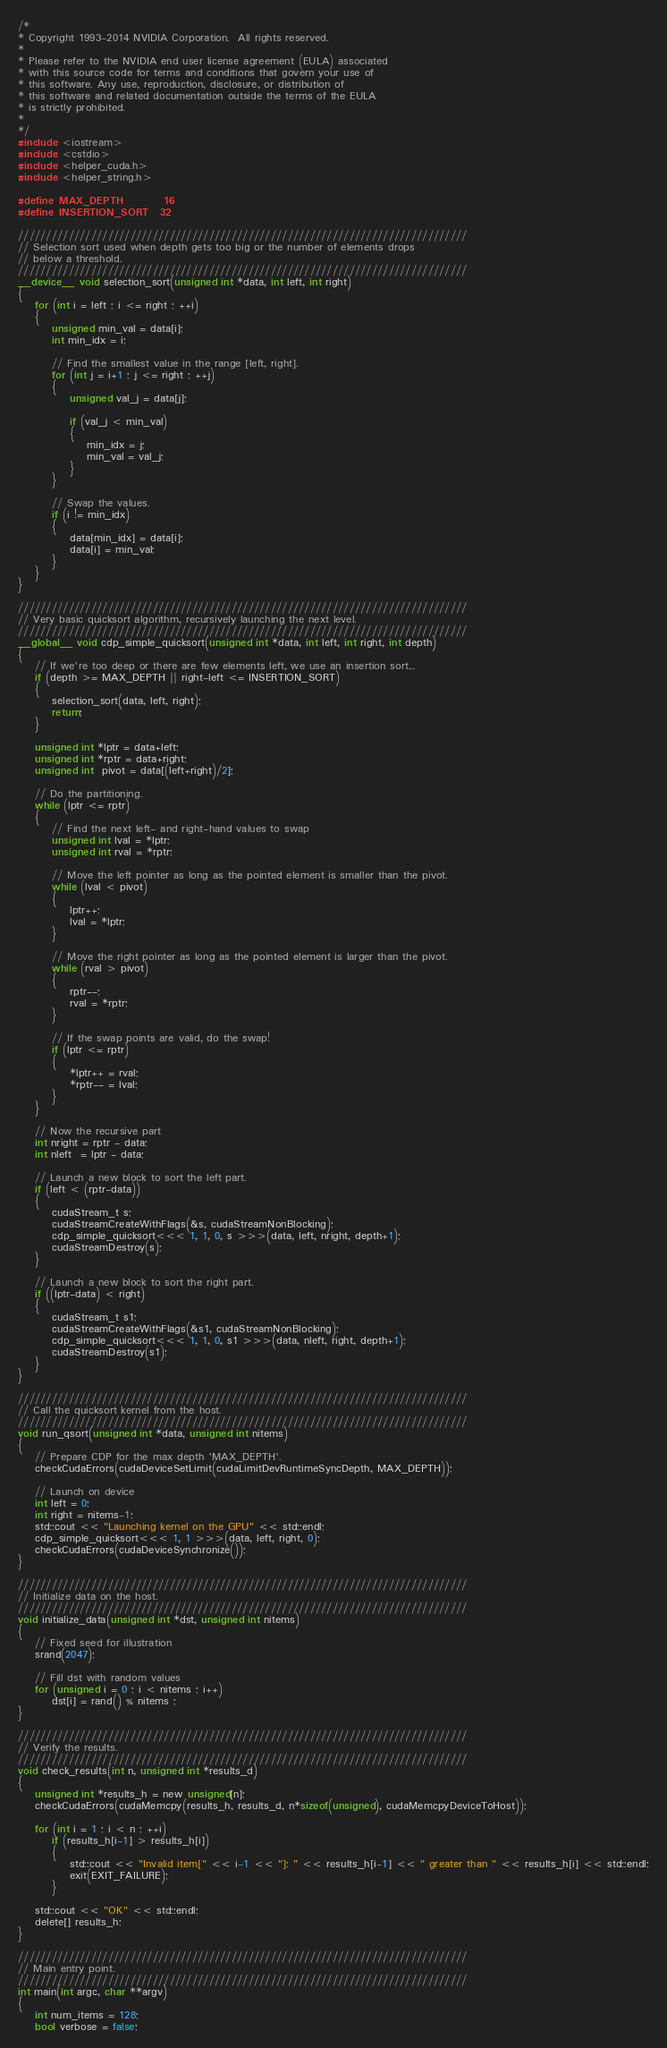<code> <loc_0><loc_0><loc_500><loc_500><_Cuda_>/*
* Copyright 1993-2014 NVIDIA Corporation.  All rights reserved.
*
* Please refer to the NVIDIA end user license agreement (EULA) associated
* with this source code for terms and conditions that govern your use of
* this software. Any use, reproduction, disclosure, or distribution of
* this software and related documentation outside the terms of the EULA
* is strictly prohibited.
*
*/
#include <iostream>
#include <cstdio>
#include <helper_cuda.h>
#include <helper_string.h>

#define MAX_DEPTH       16
#define INSERTION_SORT  32

////////////////////////////////////////////////////////////////////////////////
// Selection sort used when depth gets too big or the number of elements drops
// below a threshold.
////////////////////////////////////////////////////////////////////////////////
__device__ void selection_sort(unsigned int *data, int left, int right)
{
    for (int i = left ; i <= right ; ++i)
    {
        unsigned min_val = data[i];
        int min_idx = i;

        // Find the smallest value in the range [left, right].
        for (int j = i+1 ; j <= right ; ++j)
        {
            unsigned val_j = data[j];

            if (val_j < min_val)
            {
                min_idx = j;
                min_val = val_j;
            }
        }

        // Swap the values.
        if (i != min_idx)
        {
            data[min_idx] = data[i];
            data[i] = min_val;
        }
    }
}

////////////////////////////////////////////////////////////////////////////////
// Very basic quicksort algorithm, recursively launching the next level.
////////////////////////////////////////////////////////////////////////////////
__global__ void cdp_simple_quicksort(unsigned int *data, int left, int right, int depth)
{
    // If we're too deep or there are few elements left, we use an insertion sort...
    if (depth >= MAX_DEPTH || right-left <= INSERTION_SORT)
    {
        selection_sort(data, left, right);
        return;
    }

    unsigned int *lptr = data+left;
    unsigned int *rptr = data+right;
    unsigned int  pivot = data[(left+right)/2];

    // Do the partitioning.
    while (lptr <= rptr)
    {
        // Find the next left- and right-hand values to swap
        unsigned int lval = *lptr;
        unsigned int rval = *rptr;

        // Move the left pointer as long as the pointed element is smaller than the pivot.
        while (lval < pivot)
        {
            lptr++;
            lval = *lptr;
        }

        // Move the right pointer as long as the pointed element is larger than the pivot.
        while (rval > pivot)
        {
            rptr--;
            rval = *rptr;
        }

        // If the swap points are valid, do the swap!
        if (lptr <= rptr)
        {
            *lptr++ = rval;
            *rptr-- = lval;
        }
    }

    // Now the recursive part
    int nright = rptr - data;
    int nleft  = lptr - data;

    // Launch a new block to sort the left part.
    if (left < (rptr-data))
    {
        cudaStream_t s;
        cudaStreamCreateWithFlags(&s, cudaStreamNonBlocking);
        cdp_simple_quicksort<<< 1, 1, 0, s >>>(data, left, nright, depth+1);
        cudaStreamDestroy(s);
    }

    // Launch a new block to sort the right part.
    if ((lptr-data) < right)
    {
        cudaStream_t s1;
        cudaStreamCreateWithFlags(&s1, cudaStreamNonBlocking);
        cdp_simple_quicksort<<< 1, 1, 0, s1 >>>(data, nleft, right, depth+1);
        cudaStreamDestroy(s1);
    }
}

////////////////////////////////////////////////////////////////////////////////
// Call the quicksort kernel from the host.
////////////////////////////////////////////////////////////////////////////////
void run_qsort(unsigned int *data, unsigned int nitems)
{
    // Prepare CDP for the max depth 'MAX_DEPTH'.
    checkCudaErrors(cudaDeviceSetLimit(cudaLimitDevRuntimeSyncDepth, MAX_DEPTH));

    // Launch on device
    int left = 0;
    int right = nitems-1;
    std::cout << "Launching kernel on the GPU" << std::endl;
    cdp_simple_quicksort<<< 1, 1 >>>(data, left, right, 0);
    checkCudaErrors(cudaDeviceSynchronize());
}

////////////////////////////////////////////////////////////////////////////////
// Initialize data on the host.
////////////////////////////////////////////////////////////////////////////////
void initialize_data(unsigned int *dst, unsigned int nitems)
{
    // Fixed seed for illustration
    srand(2047);

    // Fill dst with random values
    for (unsigned i = 0 ; i < nitems ; i++)
        dst[i] = rand() % nitems ;
}

////////////////////////////////////////////////////////////////////////////////
// Verify the results.
////////////////////////////////////////////////////////////////////////////////
void check_results(int n, unsigned int *results_d)
{
    unsigned int *results_h = new unsigned[n];
    checkCudaErrors(cudaMemcpy(results_h, results_d, n*sizeof(unsigned), cudaMemcpyDeviceToHost));

    for (int i = 1 ; i < n ; ++i)
        if (results_h[i-1] > results_h[i])
        {
            std::cout << "Invalid item[" << i-1 << "]: " << results_h[i-1] << " greater than " << results_h[i] << std::endl;
            exit(EXIT_FAILURE);
        }

    std::cout << "OK" << std::endl;
    delete[] results_h;
}

////////////////////////////////////////////////////////////////////////////////
// Main entry point.
////////////////////////////////////////////////////////////////////////////////
int main(int argc, char **argv)
{
    int num_items = 128;
    bool verbose = false;</code> 